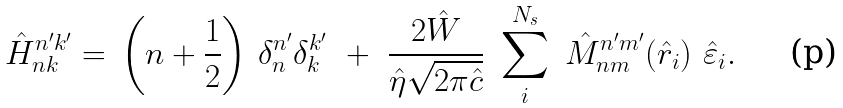Convert formula to latex. <formula><loc_0><loc_0><loc_500><loc_500>\hat { H } _ { n k } ^ { n ^ { \prime } k ^ { \prime } } = \, \left ( n + \frac { 1 } { 2 } \right ) \, \delta _ { n } ^ { n ^ { \prime } } \delta _ { k } ^ { k ^ { \prime } } \ + \ \frac { 2 \hat { W } } { \hat { \eta } \sqrt { 2 \pi \hat { c } } } \ \sum _ { i } ^ { N _ { s } } \ \hat { M } _ { n m } ^ { n ^ { \prime } m ^ { \prime } } ( \hat { r } _ { i } ) \ \hat { \varepsilon } _ { i } .</formula> 